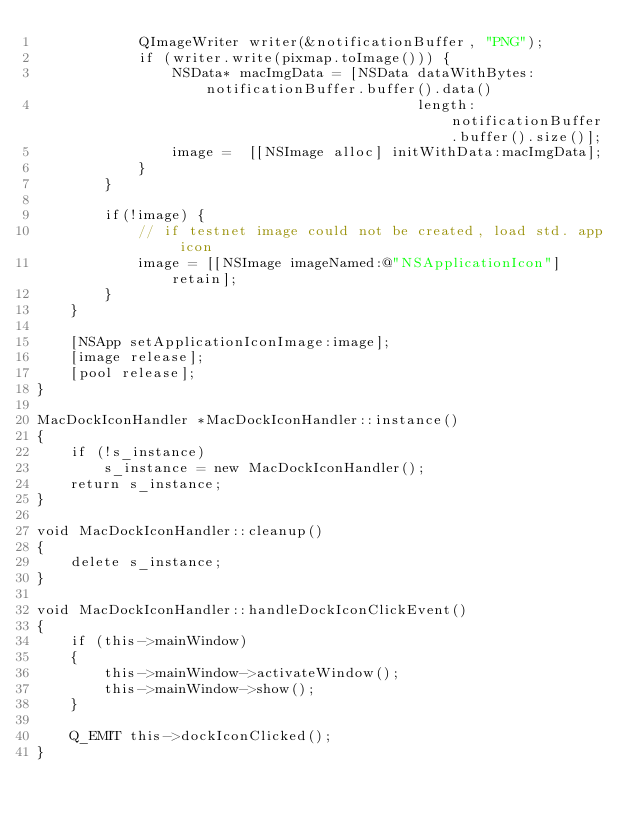<code> <loc_0><loc_0><loc_500><loc_500><_ObjectiveC_>            QImageWriter writer(&notificationBuffer, "PNG");
            if (writer.write(pixmap.toImage())) {
                NSData* macImgData = [NSData dataWithBytes:notificationBuffer.buffer().data()
                                             length:notificationBuffer.buffer().size()];
                image =  [[NSImage alloc] initWithData:macImgData];
            }
        }

        if(!image) {
            // if testnet image could not be created, load std. app icon
            image = [[NSImage imageNamed:@"NSApplicationIcon"] retain];
        }
    }

    [NSApp setApplicationIconImage:image];
    [image release];
    [pool release];
}

MacDockIconHandler *MacDockIconHandler::instance()
{
    if (!s_instance)
        s_instance = new MacDockIconHandler();
    return s_instance;
}

void MacDockIconHandler::cleanup()
{
    delete s_instance;
}

void MacDockIconHandler::handleDockIconClickEvent()
{
    if (this->mainWindow)
    {
        this->mainWindow->activateWindow();
        this->mainWindow->show();
    }

    Q_EMIT this->dockIconClicked();
}
</code> 